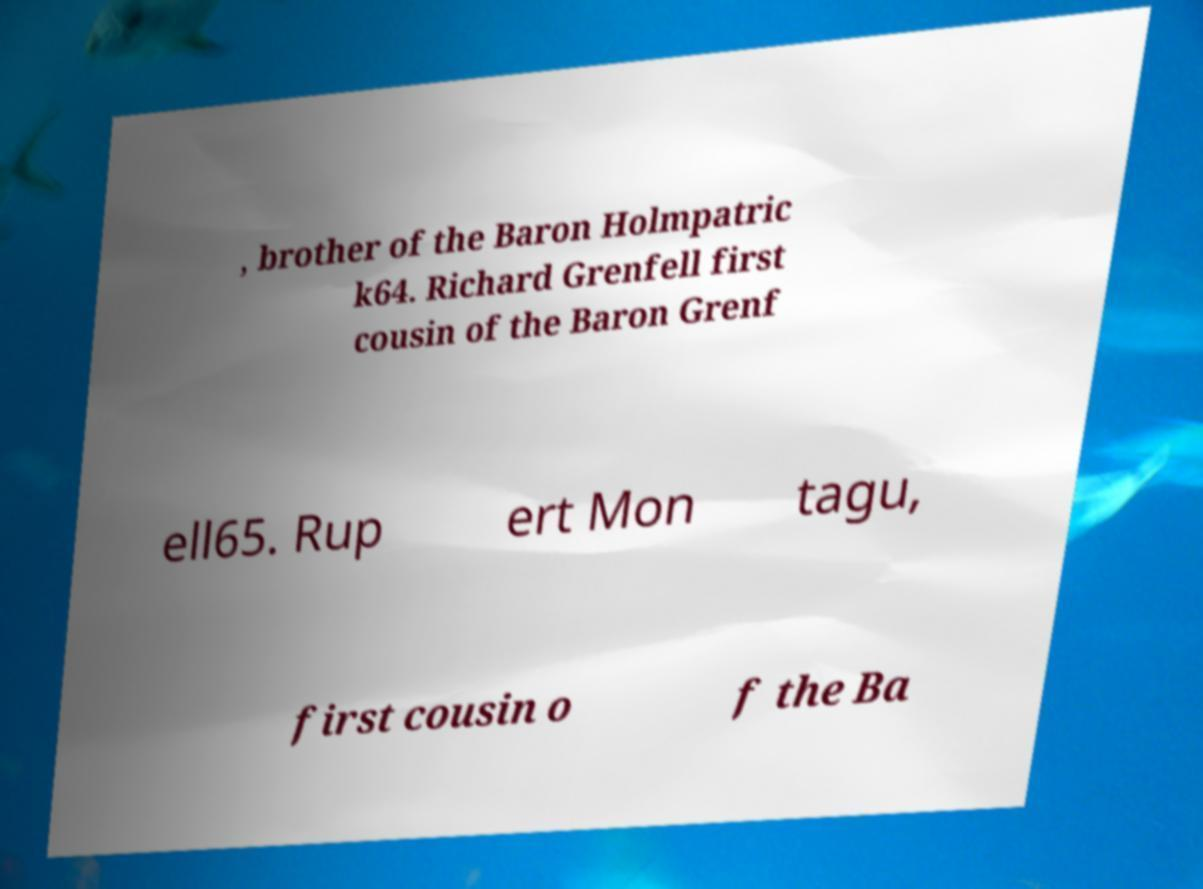There's text embedded in this image that I need extracted. Can you transcribe it verbatim? , brother of the Baron Holmpatric k64. Richard Grenfell first cousin of the Baron Grenf ell65. Rup ert Mon tagu, first cousin o f the Ba 